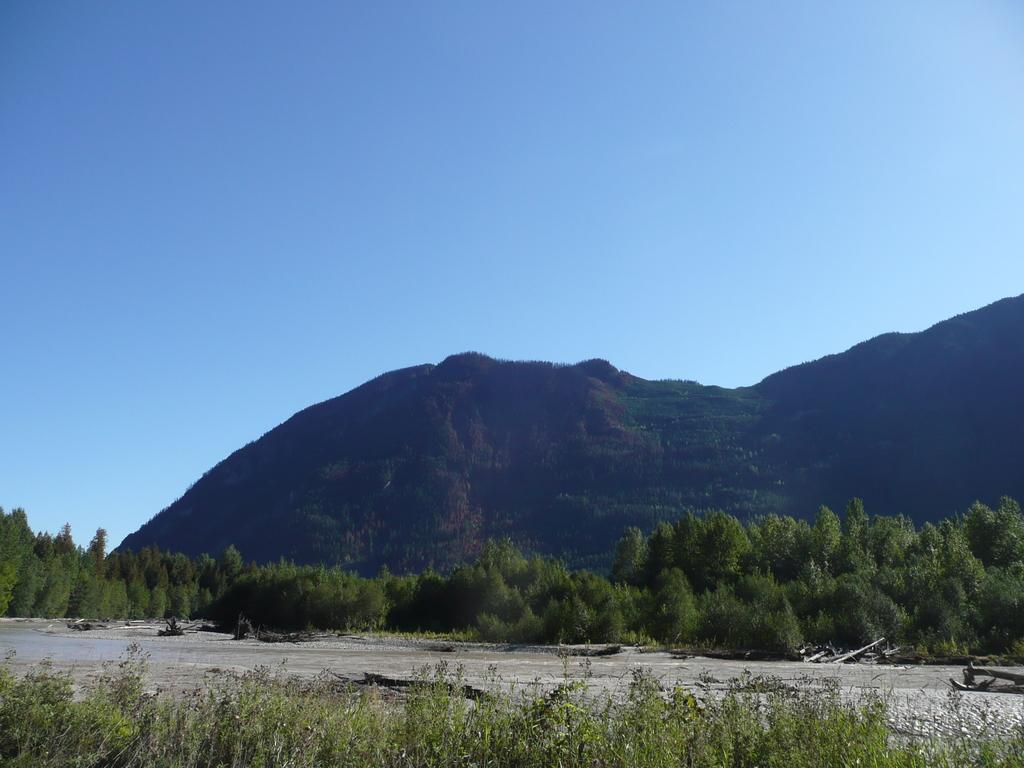What type of vegetation can be seen in the image? There are trees and plants visible in the image. What geographical feature is present in the image? There is a mountain in the image. What is the color of the sky in the image? The sky is blue in the image. What caption is written on the trees in the image? There is no caption written on the trees in the image; the trees are not labeled or described with text. Can you see any elbows in the image? There are no elbows present in the image, as it features natural elements like trees, plants, a mountain, and the sky. Is there any quicksand visible in the image? There is no quicksand present in the image; it features natural elements like trees, plants, a mountain, and the sky. 